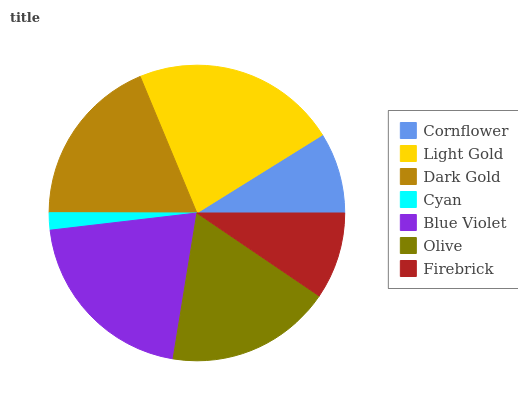Is Cyan the minimum?
Answer yes or no. Yes. Is Light Gold the maximum?
Answer yes or no. Yes. Is Dark Gold the minimum?
Answer yes or no. No. Is Dark Gold the maximum?
Answer yes or no. No. Is Light Gold greater than Dark Gold?
Answer yes or no. Yes. Is Dark Gold less than Light Gold?
Answer yes or no. Yes. Is Dark Gold greater than Light Gold?
Answer yes or no. No. Is Light Gold less than Dark Gold?
Answer yes or no. No. Is Olive the high median?
Answer yes or no. Yes. Is Olive the low median?
Answer yes or no. Yes. Is Light Gold the high median?
Answer yes or no. No. Is Cornflower the low median?
Answer yes or no. No. 